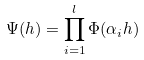Convert formula to latex. <formula><loc_0><loc_0><loc_500><loc_500>\Psi ( h ) = \prod _ { i = 1 } ^ { l } \Phi ( \alpha _ { i } h )</formula> 